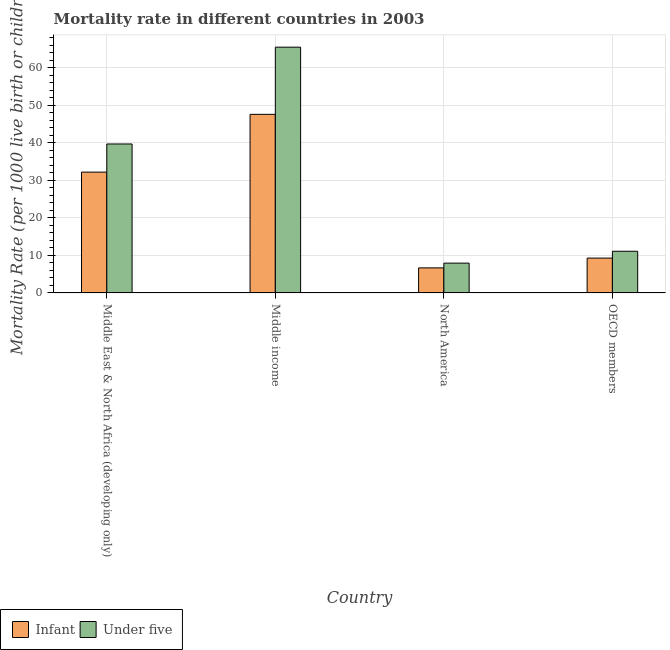How many different coloured bars are there?
Give a very brief answer. 2. How many groups of bars are there?
Make the answer very short. 4. Are the number of bars per tick equal to the number of legend labels?
Offer a very short reply. Yes. How many bars are there on the 3rd tick from the left?
Your answer should be compact. 2. In how many cases, is the number of bars for a given country not equal to the number of legend labels?
Provide a succinct answer. 0. What is the infant mortality rate in North America?
Make the answer very short. 6.68. Across all countries, what is the maximum under-5 mortality rate?
Offer a very short reply. 65.5. Across all countries, what is the minimum under-5 mortality rate?
Your answer should be compact. 7.95. In which country was the infant mortality rate maximum?
Offer a terse response. Middle income. In which country was the under-5 mortality rate minimum?
Your answer should be compact. North America. What is the total under-5 mortality rate in the graph?
Keep it short and to the point. 124.26. What is the difference between the infant mortality rate in North America and that in OECD members?
Your answer should be very brief. -2.61. What is the difference between the infant mortality rate in Middle East & North Africa (developing only) and the under-5 mortality rate in North America?
Your response must be concise. 24.25. What is the average infant mortality rate per country?
Your response must be concise. 23.94. What is the difference between the infant mortality rate and under-5 mortality rate in North America?
Ensure brevity in your answer.  -1.27. What is the ratio of the infant mortality rate in North America to that in OECD members?
Your response must be concise. 0.72. What is the difference between the highest and the second highest under-5 mortality rate?
Give a very brief answer. 25.8. What is the difference between the highest and the lowest infant mortality rate?
Make the answer very short. 40.92. What does the 1st bar from the left in North America represents?
Give a very brief answer. Infant. What does the 1st bar from the right in Middle income represents?
Keep it short and to the point. Under five. How many bars are there?
Ensure brevity in your answer.  8. How many countries are there in the graph?
Keep it short and to the point. 4. Does the graph contain any zero values?
Provide a succinct answer. No. Does the graph contain grids?
Offer a terse response. Yes. Where does the legend appear in the graph?
Keep it short and to the point. Bottom left. How are the legend labels stacked?
Give a very brief answer. Horizontal. What is the title of the graph?
Offer a terse response. Mortality rate in different countries in 2003. What is the label or title of the X-axis?
Provide a short and direct response. Country. What is the label or title of the Y-axis?
Make the answer very short. Mortality Rate (per 1000 live birth or children). What is the Mortality Rate (per 1000 live birth or children) of Infant in Middle East & North Africa (developing only)?
Give a very brief answer. 32.2. What is the Mortality Rate (per 1000 live birth or children) in Under five in Middle East & North Africa (developing only)?
Offer a terse response. 39.7. What is the Mortality Rate (per 1000 live birth or children) of Infant in Middle income?
Your answer should be very brief. 47.6. What is the Mortality Rate (per 1000 live birth or children) in Under five in Middle income?
Give a very brief answer. 65.5. What is the Mortality Rate (per 1000 live birth or children) of Infant in North America?
Your answer should be compact. 6.68. What is the Mortality Rate (per 1000 live birth or children) in Under five in North America?
Your response must be concise. 7.95. What is the Mortality Rate (per 1000 live birth or children) in Infant in OECD members?
Your response must be concise. 9.29. What is the Mortality Rate (per 1000 live birth or children) in Under five in OECD members?
Your response must be concise. 11.11. Across all countries, what is the maximum Mortality Rate (per 1000 live birth or children) of Infant?
Your response must be concise. 47.6. Across all countries, what is the maximum Mortality Rate (per 1000 live birth or children) in Under five?
Your answer should be very brief. 65.5. Across all countries, what is the minimum Mortality Rate (per 1000 live birth or children) of Infant?
Offer a very short reply. 6.68. Across all countries, what is the minimum Mortality Rate (per 1000 live birth or children) of Under five?
Keep it short and to the point. 7.95. What is the total Mortality Rate (per 1000 live birth or children) of Infant in the graph?
Your answer should be compact. 95.77. What is the total Mortality Rate (per 1000 live birth or children) in Under five in the graph?
Offer a terse response. 124.26. What is the difference between the Mortality Rate (per 1000 live birth or children) of Infant in Middle East & North Africa (developing only) and that in Middle income?
Make the answer very short. -15.4. What is the difference between the Mortality Rate (per 1000 live birth or children) in Under five in Middle East & North Africa (developing only) and that in Middle income?
Your answer should be compact. -25.8. What is the difference between the Mortality Rate (per 1000 live birth or children) of Infant in Middle East & North Africa (developing only) and that in North America?
Make the answer very short. 25.52. What is the difference between the Mortality Rate (per 1000 live birth or children) in Under five in Middle East & North Africa (developing only) and that in North America?
Your answer should be compact. 31.75. What is the difference between the Mortality Rate (per 1000 live birth or children) of Infant in Middle East & North Africa (developing only) and that in OECD members?
Make the answer very short. 22.91. What is the difference between the Mortality Rate (per 1000 live birth or children) in Under five in Middle East & North Africa (developing only) and that in OECD members?
Offer a terse response. 28.59. What is the difference between the Mortality Rate (per 1000 live birth or children) in Infant in Middle income and that in North America?
Your response must be concise. 40.92. What is the difference between the Mortality Rate (per 1000 live birth or children) in Under five in Middle income and that in North America?
Give a very brief answer. 57.55. What is the difference between the Mortality Rate (per 1000 live birth or children) in Infant in Middle income and that in OECD members?
Give a very brief answer. 38.31. What is the difference between the Mortality Rate (per 1000 live birth or children) in Under five in Middle income and that in OECD members?
Your answer should be compact. 54.39. What is the difference between the Mortality Rate (per 1000 live birth or children) in Infant in North America and that in OECD members?
Provide a short and direct response. -2.61. What is the difference between the Mortality Rate (per 1000 live birth or children) in Under five in North America and that in OECD members?
Provide a short and direct response. -3.16. What is the difference between the Mortality Rate (per 1000 live birth or children) of Infant in Middle East & North Africa (developing only) and the Mortality Rate (per 1000 live birth or children) of Under five in Middle income?
Give a very brief answer. -33.3. What is the difference between the Mortality Rate (per 1000 live birth or children) in Infant in Middle East & North Africa (developing only) and the Mortality Rate (per 1000 live birth or children) in Under five in North America?
Ensure brevity in your answer.  24.25. What is the difference between the Mortality Rate (per 1000 live birth or children) of Infant in Middle East & North Africa (developing only) and the Mortality Rate (per 1000 live birth or children) of Under five in OECD members?
Keep it short and to the point. 21.09. What is the difference between the Mortality Rate (per 1000 live birth or children) in Infant in Middle income and the Mortality Rate (per 1000 live birth or children) in Under five in North America?
Provide a short and direct response. 39.65. What is the difference between the Mortality Rate (per 1000 live birth or children) in Infant in Middle income and the Mortality Rate (per 1000 live birth or children) in Under five in OECD members?
Your response must be concise. 36.49. What is the difference between the Mortality Rate (per 1000 live birth or children) in Infant in North America and the Mortality Rate (per 1000 live birth or children) in Under five in OECD members?
Your answer should be very brief. -4.43. What is the average Mortality Rate (per 1000 live birth or children) in Infant per country?
Make the answer very short. 23.94. What is the average Mortality Rate (per 1000 live birth or children) in Under five per country?
Your response must be concise. 31.06. What is the difference between the Mortality Rate (per 1000 live birth or children) of Infant and Mortality Rate (per 1000 live birth or children) of Under five in Middle East & North Africa (developing only)?
Ensure brevity in your answer.  -7.5. What is the difference between the Mortality Rate (per 1000 live birth or children) in Infant and Mortality Rate (per 1000 live birth or children) in Under five in Middle income?
Your answer should be compact. -17.9. What is the difference between the Mortality Rate (per 1000 live birth or children) in Infant and Mortality Rate (per 1000 live birth or children) in Under five in North America?
Your answer should be compact. -1.27. What is the difference between the Mortality Rate (per 1000 live birth or children) of Infant and Mortality Rate (per 1000 live birth or children) of Under five in OECD members?
Offer a very short reply. -1.82. What is the ratio of the Mortality Rate (per 1000 live birth or children) of Infant in Middle East & North Africa (developing only) to that in Middle income?
Give a very brief answer. 0.68. What is the ratio of the Mortality Rate (per 1000 live birth or children) in Under five in Middle East & North Africa (developing only) to that in Middle income?
Offer a terse response. 0.61. What is the ratio of the Mortality Rate (per 1000 live birth or children) in Infant in Middle East & North Africa (developing only) to that in North America?
Offer a very short reply. 4.82. What is the ratio of the Mortality Rate (per 1000 live birth or children) in Under five in Middle East & North Africa (developing only) to that in North America?
Make the answer very short. 4.99. What is the ratio of the Mortality Rate (per 1000 live birth or children) in Infant in Middle East & North Africa (developing only) to that in OECD members?
Ensure brevity in your answer.  3.47. What is the ratio of the Mortality Rate (per 1000 live birth or children) of Under five in Middle East & North Africa (developing only) to that in OECD members?
Offer a very short reply. 3.57. What is the ratio of the Mortality Rate (per 1000 live birth or children) of Infant in Middle income to that in North America?
Your answer should be very brief. 7.13. What is the ratio of the Mortality Rate (per 1000 live birth or children) of Under five in Middle income to that in North America?
Keep it short and to the point. 8.24. What is the ratio of the Mortality Rate (per 1000 live birth or children) in Infant in Middle income to that in OECD members?
Give a very brief answer. 5.12. What is the ratio of the Mortality Rate (per 1000 live birth or children) in Under five in Middle income to that in OECD members?
Your response must be concise. 5.9. What is the ratio of the Mortality Rate (per 1000 live birth or children) in Infant in North America to that in OECD members?
Your response must be concise. 0.72. What is the ratio of the Mortality Rate (per 1000 live birth or children) of Under five in North America to that in OECD members?
Make the answer very short. 0.72. What is the difference between the highest and the second highest Mortality Rate (per 1000 live birth or children) in Under five?
Your answer should be very brief. 25.8. What is the difference between the highest and the lowest Mortality Rate (per 1000 live birth or children) in Infant?
Give a very brief answer. 40.92. What is the difference between the highest and the lowest Mortality Rate (per 1000 live birth or children) in Under five?
Your response must be concise. 57.55. 